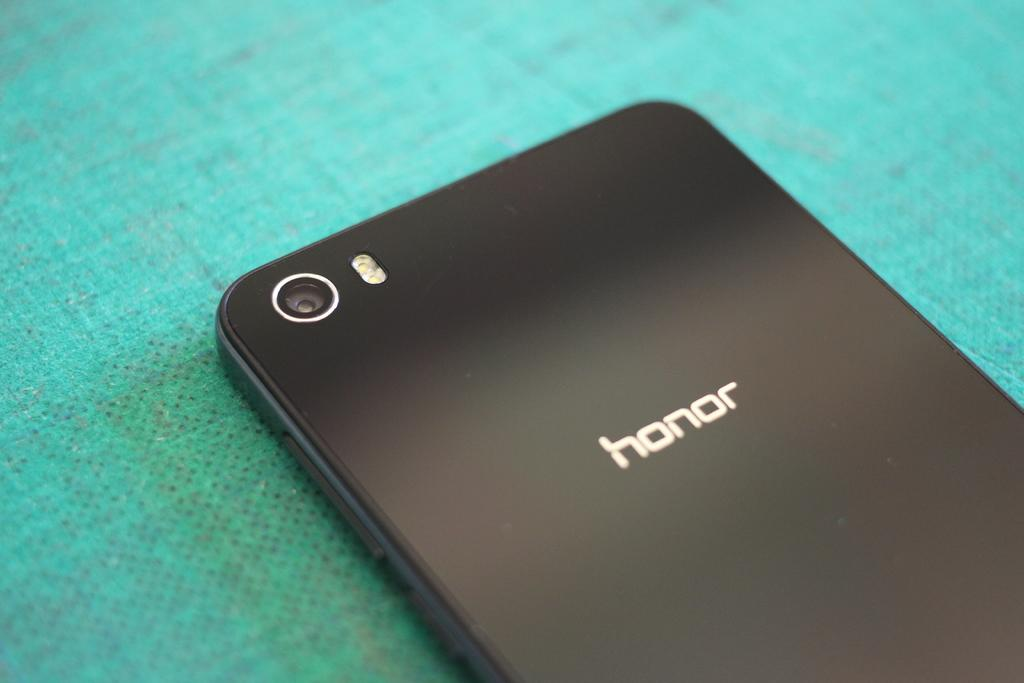<image>
Describe the image concisely. A honor cell phone sits backside up on a teal table cloth. 